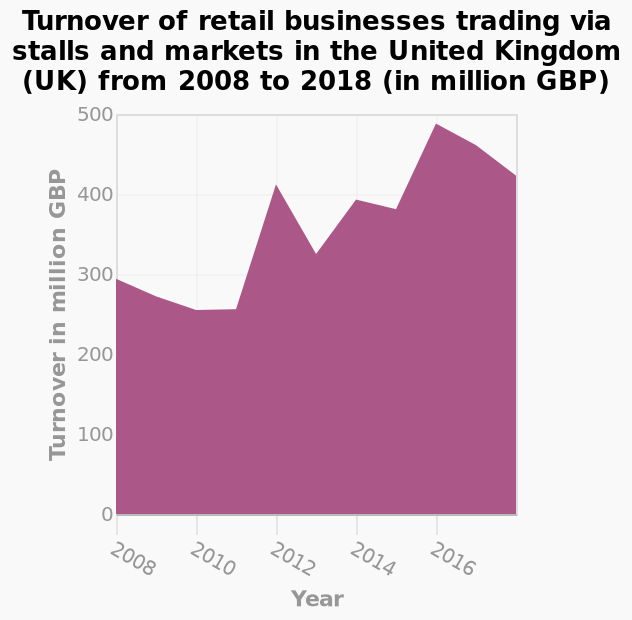<image>
What was the turnover of retail businesses trading via stalls and markets in the UK in 2015? The turnover of retail businesses trading via stalls and markets in the UK in 2015 was just below 500 million. please enumerates aspects of the construction of the chart Turnover of retail businesses trading via stalls and markets in the United Kingdom (UK) from 2008 to 2018 (in million GBP) is a area plot. The y-axis shows Turnover in million GBP on linear scale from 0 to 500 while the x-axis plots Year along linear scale of range 2008 to 2016. please summary the statistics and relations of the chart Between 2008 and 2016 the turnover of retail businesses trading via stalls and markets in the UK has increased from below 300  million to over 400 million. Turnover dropped between 2008 and 2010. Turnover peaked in 2015 at just below 500 million. 